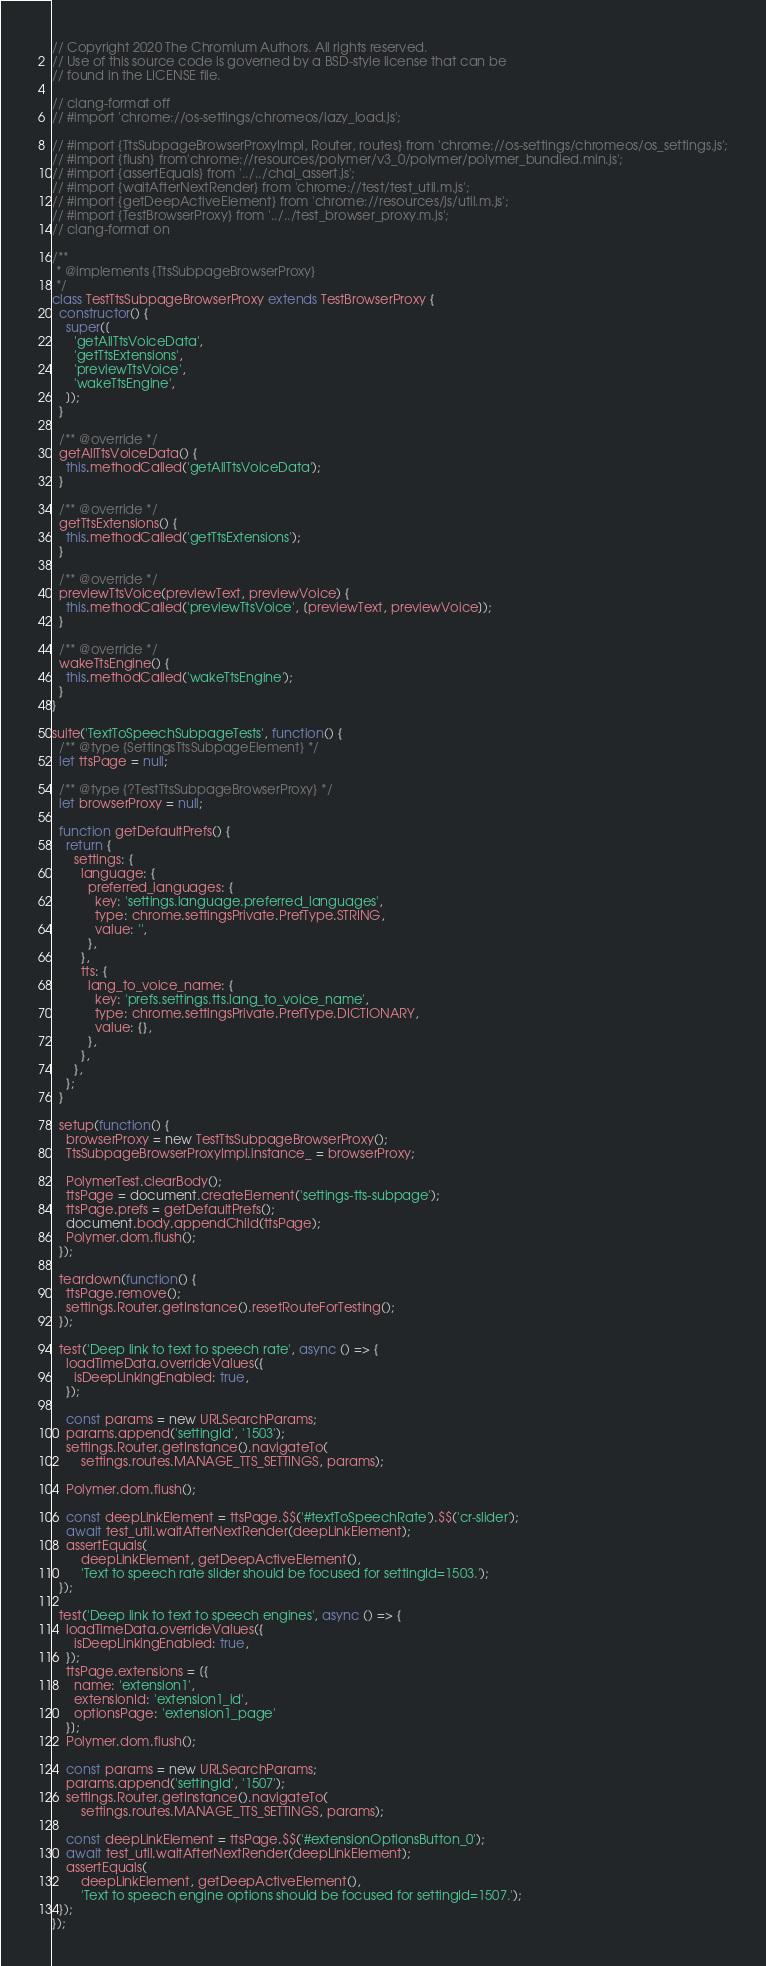<code> <loc_0><loc_0><loc_500><loc_500><_JavaScript_>// Copyright 2020 The Chromium Authors. All rights reserved.
// Use of this source code is governed by a BSD-style license that can be
// found in the LICENSE file.

// clang-format off
// #import 'chrome://os-settings/chromeos/lazy_load.js';

// #import {TtsSubpageBrowserProxyImpl, Router, routes} from 'chrome://os-settings/chromeos/os_settings.js';
// #import {flush} from'chrome://resources/polymer/v3_0/polymer/polymer_bundled.min.js';
// #import {assertEquals} from '../../chai_assert.js';
// #import {waitAfterNextRender} from 'chrome://test/test_util.m.js';
// #import {getDeepActiveElement} from 'chrome://resources/js/util.m.js';
// #import {TestBrowserProxy} from '../../test_browser_proxy.m.js';
// clang-format on

/**
 * @implements {TtsSubpageBrowserProxy}
 */
class TestTtsSubpageBrowserProxy extends TestBrowserProxy {
  constructor() {
    super([
      'getAllTtsVoiceData',
      'getTtsExtensions',
      'previewTtsVoice',
      'wakeTtsEngine',
    ]);
  }

  /** @override */
  getAllTtsVoiceData() {
    this.methodCalled('getAllTtsVoiceData');
  }

  /** @override */
  getTtsExtensions() {
    this.methodCalled('getTtsExtensions');
  }

  /** @override */
  previewTtsVoice(previewText, previewVoice) {
    this.methodCalled('previewTtsVoice', [previewText, previewVoice]);
  }

  /** @override */
  wakeTtsEngine() {
    this.methodCalled('wakeTtsEngine');
  }
}

suite('TextToSpeechSubpageTests', function() {
  /** @type {SettingsTtsSubpageElement} */
  let ttsPage = null;

  /** @type {?TestTtsSubpageBrowserProxy} */
  let browserProxy = null;

  function getDefaultPrefs() {
    return {
      settings: {
        language: {
          preferred_languages: {
            key: 'settings.language.preferred_languages',
            type: chrome.settingsPrivate.PrefType.STRING,
            value: '',
          },
        },
        tts: {
          lang_to_voice_name: {
            key: 'prefs.settings.tts.lang_to_voice_name',
            type: chrome.settingsPrivate.PrefType.DICTIONARY,
            value: {},
          },
        },
      },
    };
  }

  setup(function() {
    browserProxy = new TestTtsSubpageBrowserProxy();
    TtsSubpageBrowserProxyImpl.instance_ = browserProxy;

    PolymerTest.clearBody();
    ttsPage = document.createElement('settings-tts-subpage');
    ttsPage.prefs = getDefaultPrefs();
    document.body.appendChild(ttsPage);
    Polymer.dom.flush();
  });

  teardown(function() {
    ttsPage.remove();
    settings.Router.getInstance().resetRouteForTesting();
  });

  test('Deep link to text to speech rate', async () => {
    loadTimeData.overrideValues({
      isDeepLinkingEnabled: true,
    });

    const params = new URLSearchParams;
    params.append('settingId', '1503');
    settings.Router.getInstance().navigateTo(
        settings.routes.MANAGE_TTS_SETTINGS, params);

    Polymer.dom.flush();

    const deepLinkElement = ttsPage.$$('#textToSpeechRate').$$('cr-slider');
    await test_util.waitAfterNextRender(deepLinkElement);
    assertEquals(
        deepLinkElement, getDeepActiveElement(),
        'Text to speech rate slider should be focused for settingId=1503.');
  });

  test('Deep link to text to speech engines', async () => {
    loadTimeData.overrideValues({
      isDeepLinkingEnabled: true,
    });
    ttsPage.extensions = [{
      name: 'extension1',
      extensionId: 'extension1_id',
      optionsPage: 'extension1_page'
    }];
    Polymer.dom.flush();

    const params = new URLSearchParams;
    params.append('settingId', '1507');
    settings.Router.getInstance().navigateTo(
        settings.routes.MANAGE_TTS_SETTINGS, params);

    const deepLinkElement = ttsPage.$$('#extensionOptionsButton_0');
    await test_util.waitAfterNextRender(deepLinkElement);
    assertEquals(
        deepLinkElement, getDeepActiveElement(),
        'Text to speech engine options should be focused for settingId=1507.');
  });
});</code> 